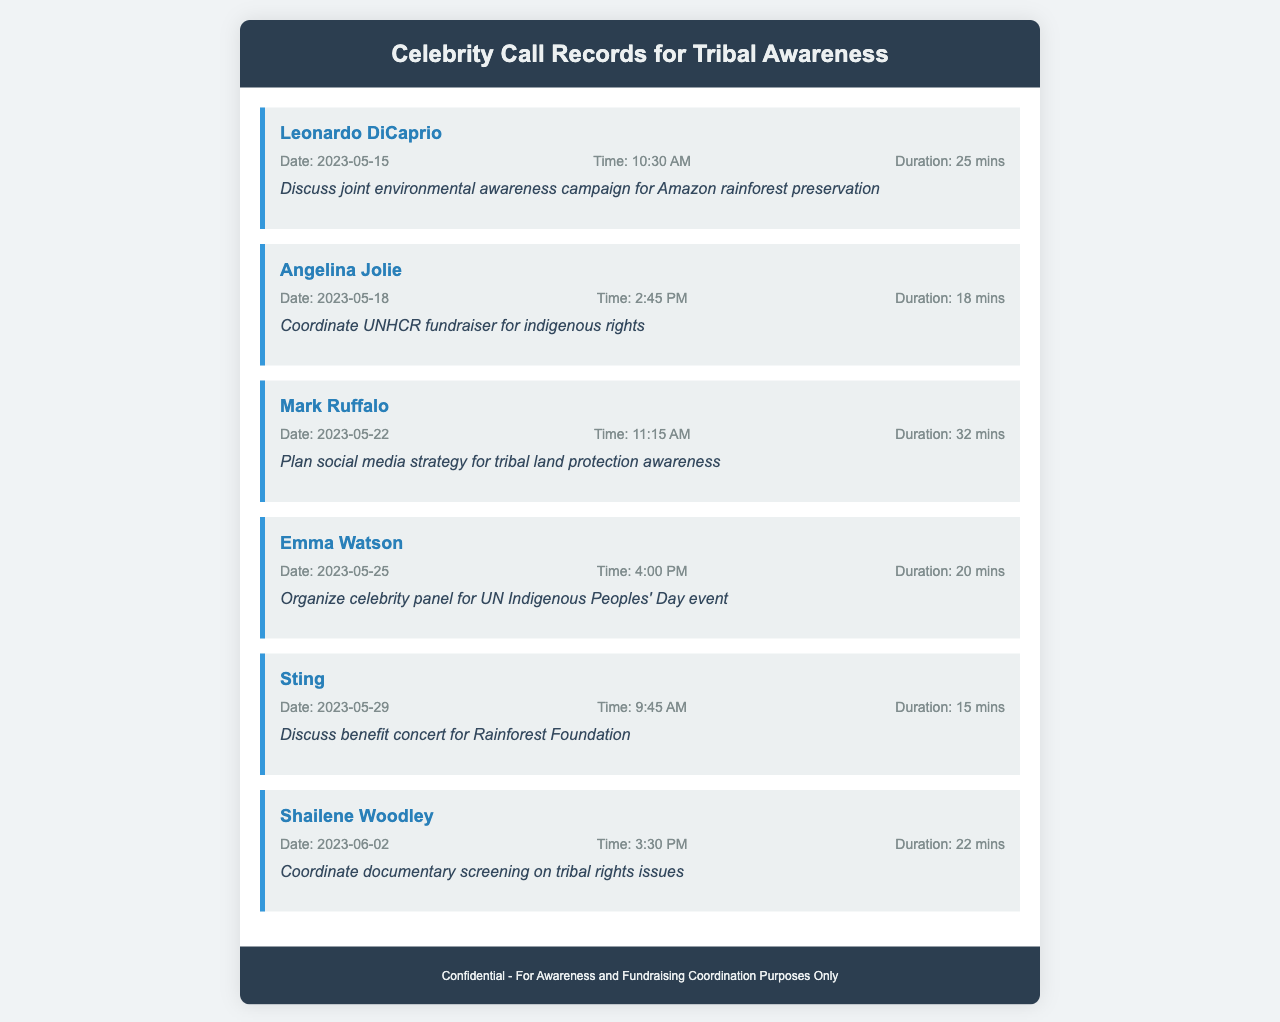What is the name of the first celebrity called? The first celebrity mentioned in the call records is Leonardo DiCaprio.
Answer: Leonardo DiCaprio How long did the call with Angelina Jolie last? The duration of the call with Angelina Jolie is specifically recorded as 18 minutes.
Answer: 18 mins What is the main purpose of the call with Mark Ruffalo? The main purpose of the call is to plan a social media strategy for raising awareness of tribal land protection.
Answer: Plan social media strategy for tribal land protection awareness On which date did the call with Emma Watson take place? The call with Emma Watson occurred on May 25, 2023.
Answer: 2023-05-25 Who was involved in discussing a benefit concert for the Rainforest Foundation? The celebrity who discussed this was Sting.
Answer: Sting Which call had the longest duration? The call that lasted the longest is with Mark Ruffalo, which was 32 minutes long.
Answer: 32 mins What date was the call with Shailene Woodley? The date of the call with Shailene Woodley is June 2, 2023.
Answer: 2023-06-02 How many calls are listed in the document? There are a total of six calls recorded in the document.
Answer: Six What was the purpose of the call with Leonardo DiCaprio? The purpose of the call was to discuss a joint environmental awareness campaign for Amazon rainforest preservation.
Answer: Discuss joint environmental awareness campaign for Amazon rainforest preservation What time was the call with Sting? The time of the call with Sting was 9:45 AM.
Answer: 9:45 AM 